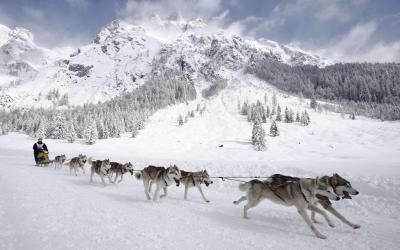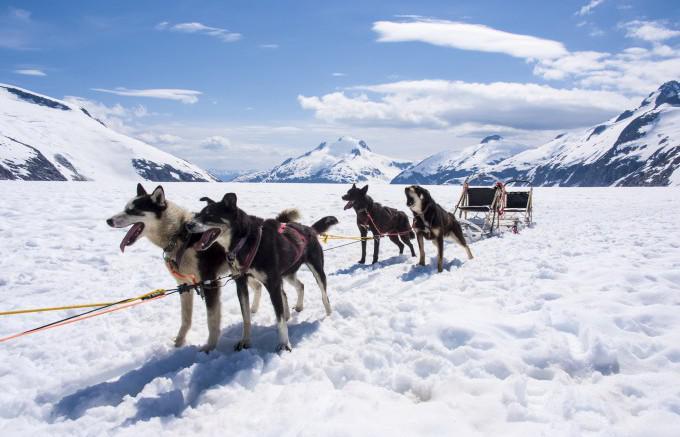The first image is the image on the left, the second image is the image on the right. Evaluate the accuracy of this statement regarding the images: "In one of the images, a dogsled is headed towards the left.". Is it true? Answer yes or no. Yes. The first image is the image on the left, the second image is the image on the right. Examine the images to the left and right. Is the description "The dog team in the left image is heading right, and the dog team in the right image is heading left." accurate? Answer yes or no. Yes. 